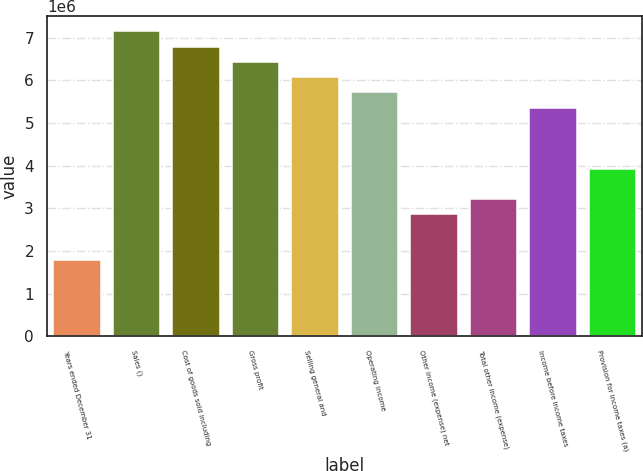Convert chart. <chart><loc_0><loc_0><loc_500><loc_500><bar_chart><fcel>Years ended December 31<fcel>Sales ()<fcel>Cost of goods sold including<fcel>Gross profit<fcel>Selling general and<fcel>Operating income<fcel>Other income (expense) net<fcel>Total other income (expense)<fcel>Income before income taxes<fcel>Provision for income taxes (a)<nl><fcel>1.78828e+06<fcel>7.1531e+06<fcel>6.79545e+06<fcel>6.43779e+06<fcel>6.08014e+06<fcel>5.72248e+06<fcel>2.86124e+06<fcel>3.2189e+06<fcel>5.36483e+06<fcel>3.93421e+06<nl></chart> 